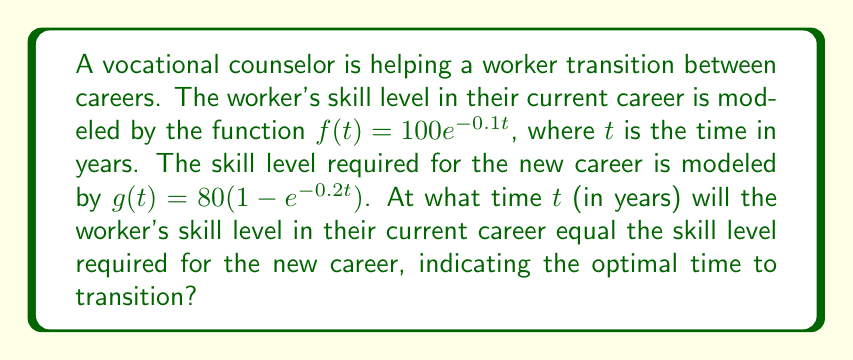Show me your answer to this math problem. To find the optimal time for career transition, we need to find the intersection point of the two functions $f(t)$ and $g(t)$. This occurs when:

$$f(t) = g(t)$$

Step 1: Substitute the given functions:
$$100e^{-0.1t} = 80(1-e^{-0.2t})$$

Step 2: Expand the right side of the equation:
$$100e^{-0.1t} = 80 - 80e^{-0.2t}$$

Step 3: Add $80e^{-0.2t}$ to both sides:
$$100e^{-0.1t} + 80e^{-0.2t} = 80$$

Step 4: Divide both sides by 80:
$$1.25e^{-0.1t} + e^{-0.2t} = 1$$

Step 5: Let $u = e^{-0.1t}$. Then $e^{-0.2t} = u^2$:
$$1.25u + u^2 = 1$$

Step 6: Rearrange to standard quadratic form:
$$u^2 + 1.25u - 1 = 0$$

Step 7: Solve using the quadratic formula, $u = \frac{-b \pm \sqrt{b^2 - 4ac}}{2a}$:

$$u = \frac{-1.25 \pm \sqrt{1.25^2 - 4(1)(-1)}}{2(1)}$$

$$u = \frac{-1.25 \pm \sqrt{1.5625 + 4}}{2} = \frac{-1.25 \pm \sqrt{5.5625}}{2}$$

$$u = \frac{-1.25 \pm 2.3585}{2}$$

Step 8: Take the positive root (as $u = e^{-0.1t}$ must be positive):
$$u = \frac{-1.25 + 2.3585}{2} = 0.55425$$

Step 9: Solve for $t$:
$$e^{-0.1t} = 0.55425$$
$$-0.1t = \ln(0.55425)$$
$$t = -\frac{\ln(0.55425)}{0.1} \approx 5.9026$$

Therefore, the optimal time for career transition is approximately 5.9026 years.
Answer: 5.9026 years 